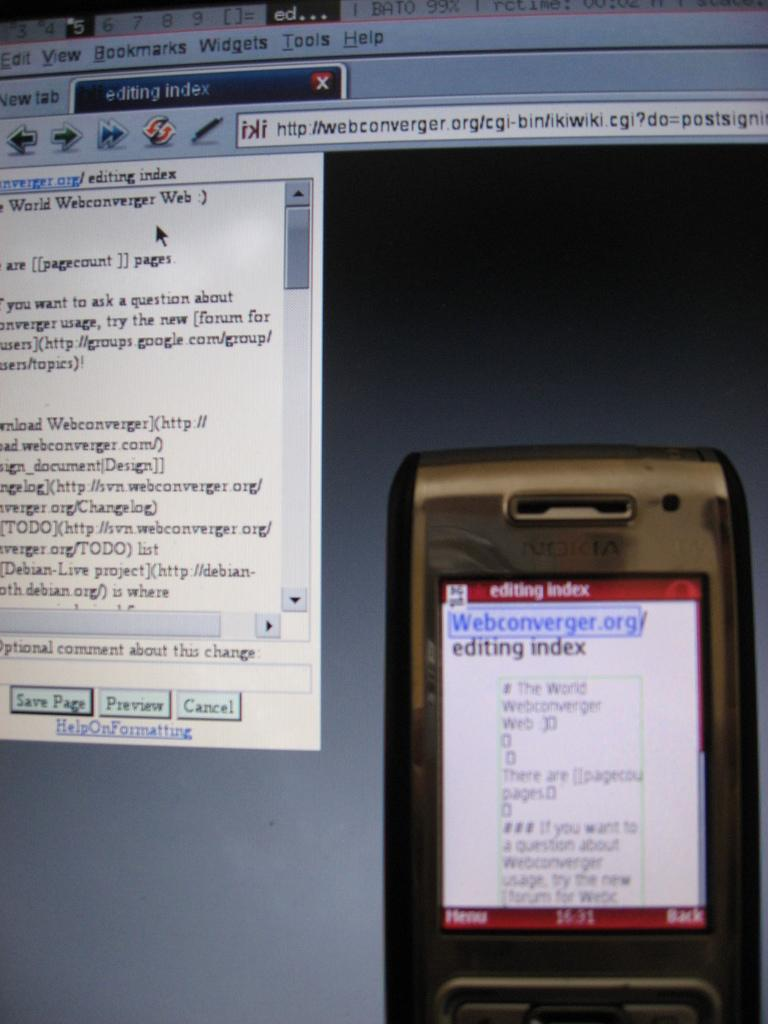Provide a one-sentence caption for the provided image. The device is used for editing with a tool call webconverger. 